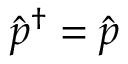Convert formula to latex. <formula><loc_0><loc_0><loc_500><loc_500>\hat { p } ^ { \dagger } = \hat { p }</formula> 